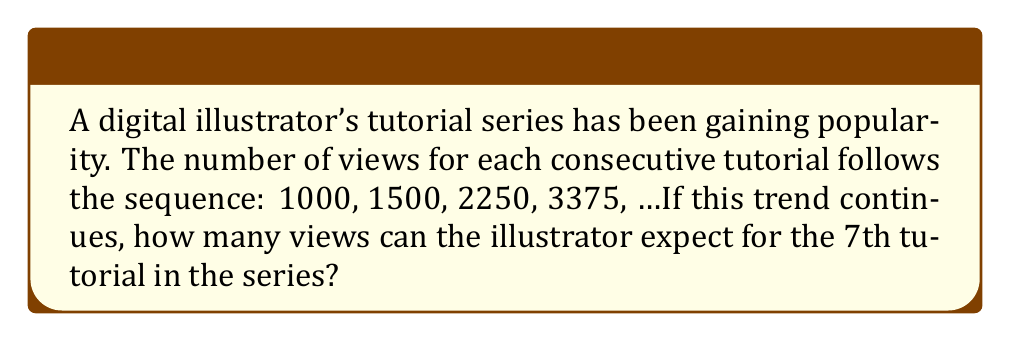Help me with this question. Let's approach this step-by-step:

1) First, we need to identify the pattern in the sequence:
   1000, 1500, 2250, 3375, ...

2) To find the pattern, let's calculate the ratio between consecutive terms:
   1500 / 1000 = 1.5
   2250 / 1500 = 1.5
   3375 / 2250 = 1.5

3) We can see that each term is 1.5 times the previous term. This is a geometric sequence with a common ratio of 1.5.

4) The general formula for a geometric sequence is:
   $$a_n = a_1 \cdot r^{n-1}$$
   Where $a_n$ is the nth term, $a_1$ is the first term, r is the common ratio, and n is the position of the term.

5) In this case:
   $a_1 = 1000$ (first term)
   $r = 1.5$ (common ratio)
   We need to find $a_7$ (7th term)

6) Plugging these values into the formula:
   $$a_7 = 1000 \cdot 1.5^{7-1}$$
   $$a_7 = 1000 \cdot 1.5^6$$

7) Calculate:
   $$a_7 = 1000 \cdot 11.390625 = 11,390.625$$

8) Since we're dealing with views, we round to the nearest whole number:
   11,391 views
Answer: 11,391 views 